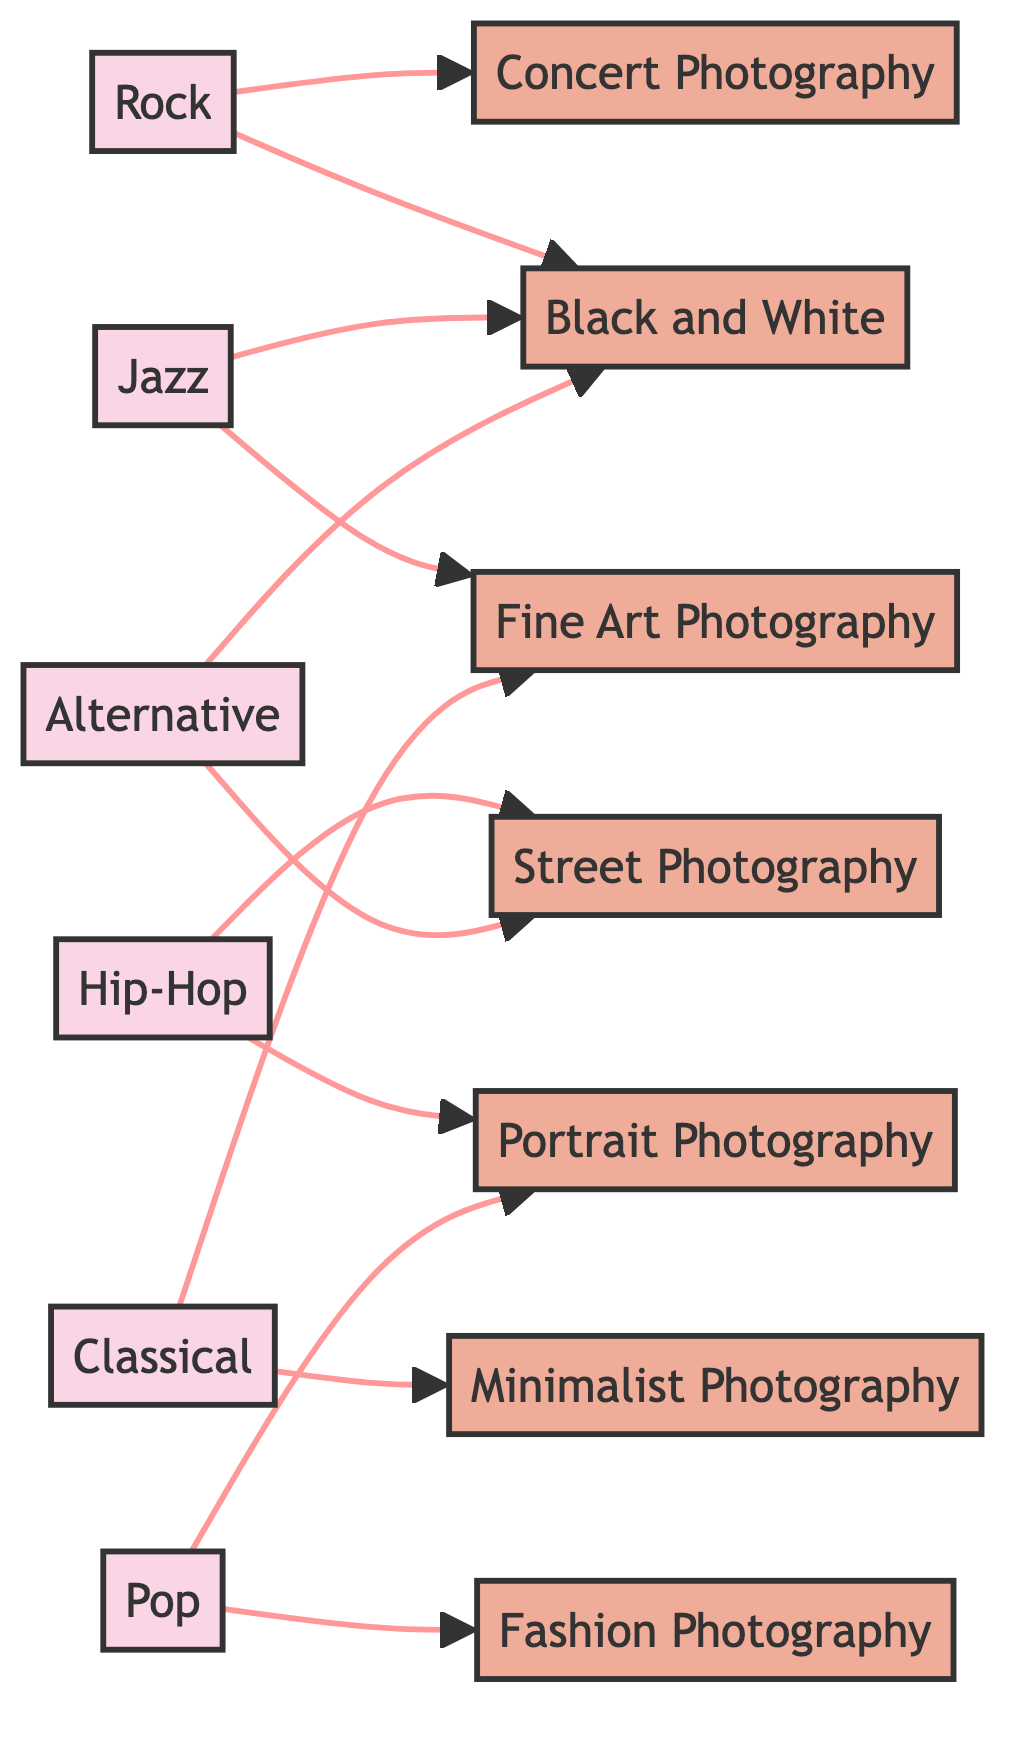What music genre is connected to concert photography? The diagram shows that "Rock" has a direct connection (edge) to "Concert Photography". By looking at the relationships depicted, you can quickly identify which music genre corresponds to which photography style.
Answer: Rock How many photography styles are shown in this diagram? The nodes include various photography styles, and counting each unique photography style node reveals there are 6 different styles listed.
Answer: 6 What is the connection between jazz and black and white photography? In the diagram, "Jazz" is directly linked to "Black and White" by an edge. This means there is an established relationship indicating how jazz influences that style of photography.
Answer: Yes Which music genre is associated with fashion photography? The diagram clearly shows that "Pop" is connected to "Fashion Photography". You can trace this relationship directly via the edge from "Pop" to that photography style.
Answer: Pop How many total connections (edges) are depicted in the diagram? By counting the directed edges that connect the music genres to photography styles in the diagram, it is evident that there are 12 connections total.
Answer: 12 Which photography style is influenced by both hip-hop and alternative music genres? The diagram indicates that "Street Photography" is connected to both "Hip-Hop" and "Alternative". You can see the direct edges emanating from both genres leading to this particular style.
Answer: Street Photography Is there any music genre that connects to multiple photography styles? Yes, the diagram shows that certain music genres like "Pop" connect to more than one photography style, specifically to both "Fashion Photography" and "Portrait Photography". This indicates how multiple styles can be influenced by a single genre.
Answer: Yes Which genre has only one connection in the diagram? If you examine the connections, "Classical" has two edges leading to "Fine Art Photography" and "Minimalist Photography", while all others connect to at least two styles. In contrast, "Rock" connects to two, like many genres, thus "Pop" is not unique in this descriptive.
Answer: None 